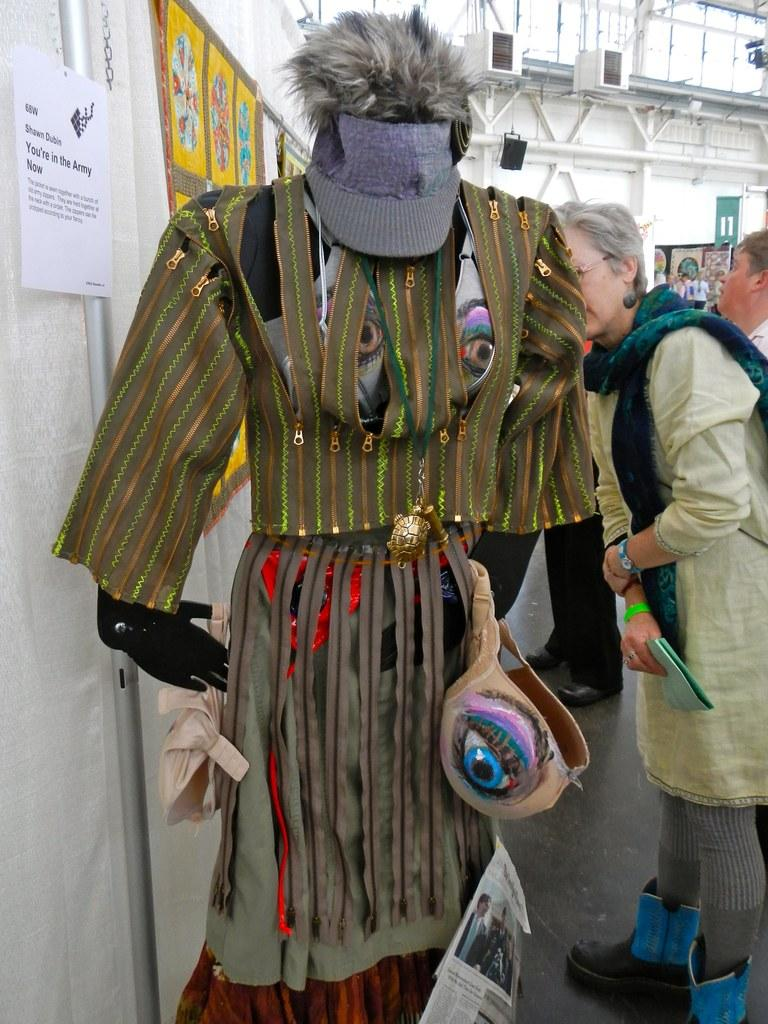What type of items can be seen in the image? There are clothes, paper, people, a pole, and posters in the image. Can you describe the setting of the image? The image features a building in the background and objects in the background. What might the people in the image be doing? It is not clear from the image what the people are doing, but they are likely interacting with the clothes, paper, pole, and posters. What type of lamp can be seen in the image? There is no lamp present in the image. What sound can be heard coming from the bells in the image? There are no bells present in the image, so it is not possible to determine what sound might be heard. 